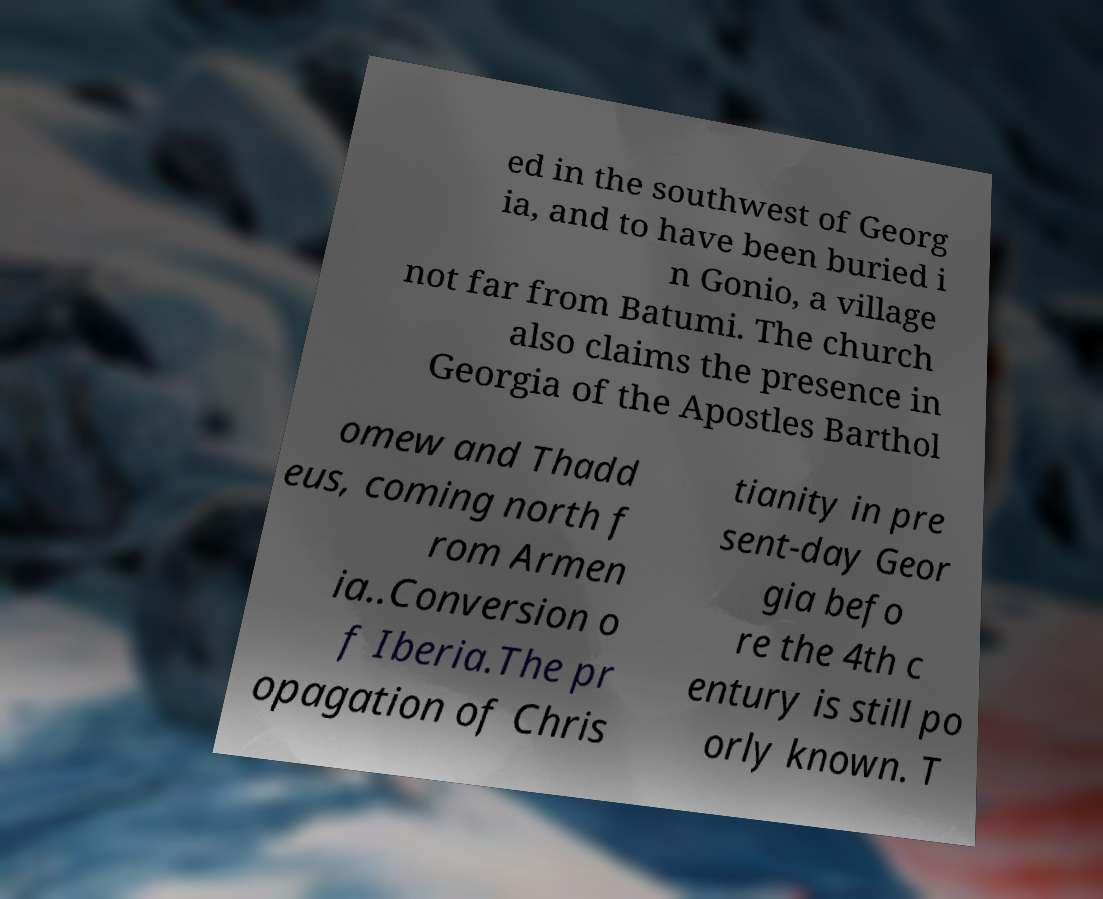Please identify and transcribe the text found in this image. ed in the southwest of Georg ia, and to have been buried i n Gonio, a village not far from Batumi. The church also claims the presence in Georgia of the Apostles Barthol omew and Thadd eus, coming north f rom Armen ia..Conversion o f Iberia.The pr opagation of Chris tianity in pre sent-day Geor gia befo re the 4th c entury is still po orly known. T 